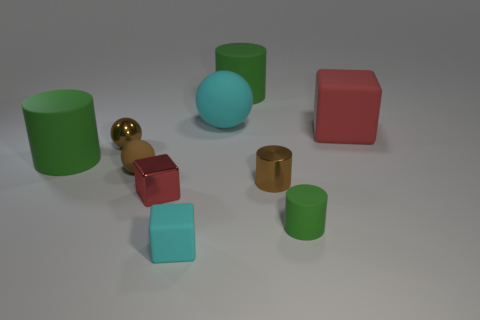Subtract all tiny cubes. How many cubes are left? 1 Subtract all cyan cubes. How many green cylinders are left? 3 Subtract all brown cylinders. How many cylinders are left? 3 Subtract 2 cylinders. How many cylinders are left? 2 Subtract all gray cylinders. Subtract all brown balls. How many cylinders are left? 4 Subtract all cylinders. How many objects are left? 6 Add 1 cylinders. How many cylinders exist? 5 Subtract 0 gray balls. How many objects are left? 10 Subtract all big shiny cylinders. Subtract all big green objects. How many objects are left? 8 Add 4 cyan balls. How many cyan balls are left? 5 